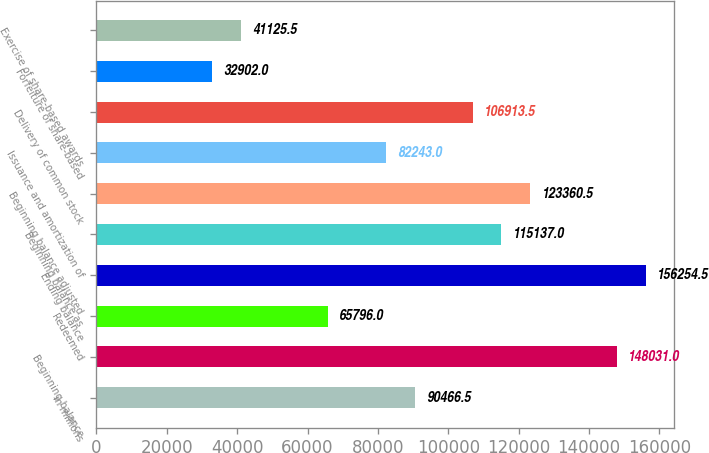Convert chart to OTSL. <chart><loc_0><loc_0><loc_500><loc_500><bar_chart><fcel>in millions<fcel>Beginning balance<fcel>Redeemed<fcel>Ending balance<fcel>Beginning balance as<fcel>Beginning balance adjusted<fcel>Issuance and amortization of<fcel>Delivery of common stock<fcel>Forfeiture of share-based<fcel>Exercise of share-based awards<nl><fcel>90466.5<fcel>148031<fcel>65796<fcel>156254<fcel>115137<fcel>123360<fcel>82243<fcel>106914<fcel>32902<fcel>41125.5<nl></chart> 